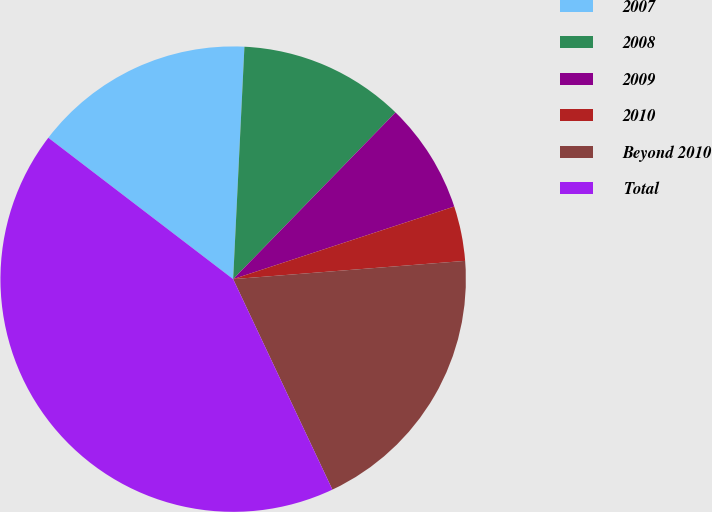Convert chart to OTSL. <chart><loc_0><loc_0><loc_500><loc_500><pie_chart><fcel>2007<fcel>2008<fcel>2009<fcel>2010<fcel>Beyond 2010<fcel>Total<nl><fcel>15.38%<fcel>11.52%<fcel>7.66%<fcel>3.8%<fcel>19.24%<fcel>42.41%<nl></chart> 